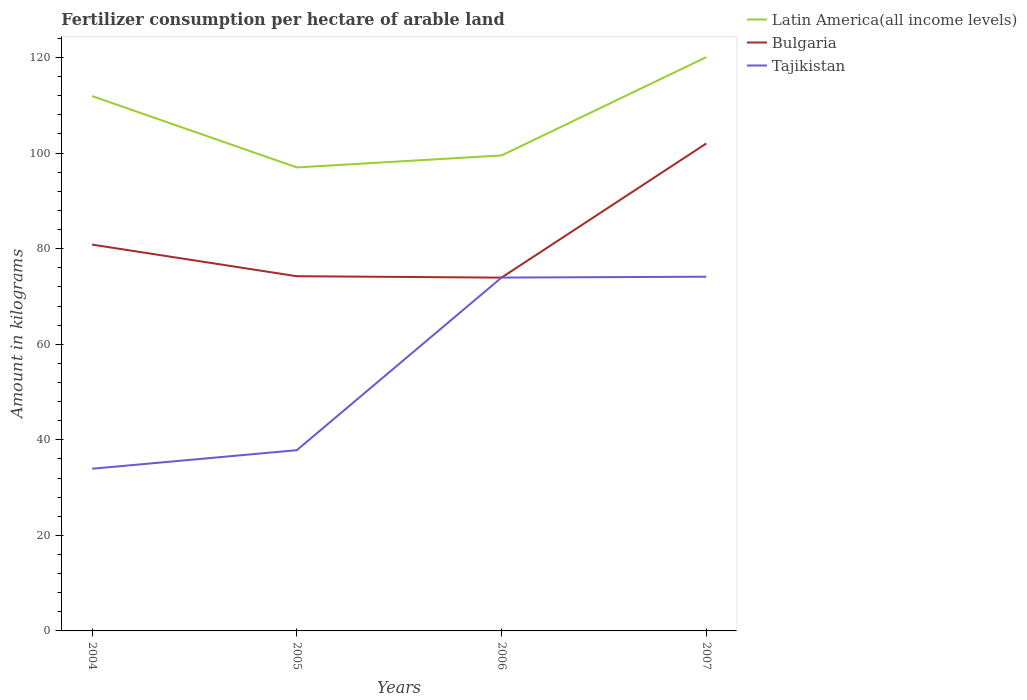Is the number of lines equal to the number of legend labels?
Keep it short and to the point. Yes. Across all years, what is the maximum amount of fertilizer consumption in Bulgaria?
Make the answer very short. 73.94. In which year was the amount of fertilizer consumption in Tajikistan maximum?
Offer a terse response. 2004. What is the total amount of fertilizer consumption in Latin America(all income levels) in the graph?
Your answer should be very brief. -20.57. What is the difference between the highest and the second highest amount of fertilizer consumption in Tajikistan?
Your response must be concise. 40.19. What is the difference between the highest and the lowest amount of fertilizer consumption in Latin America(all income levels)?
Offer a terse response. 2. Is the amount of fertilizer consumption in Bulgaria strictly greater than the amount of fertilizer consumption in Latin America(all income levels) over the years?
Provide a succinct answer. Yes. How many years are there in the graph?
Your answer should be compact. 4. What is the title of the graph?
Offer a very short reply. Fertilizer consumption per hectare of arable land. What is the label or title of the X-axis?
Your answer should be very brief. Years. What is the label or title of the Y-axis?
Keep it short and to the point. Amount in kilograms. What is the Amount in kilograms in Latin America(all income levels) in 2004?
Make the answer very short. 111.94. What is the Amount in kilograms in Bulgaria in 2004?
Provide a succinct answer. 80.85. What is the Amount in kilograms of Tajikistan in 2004?
Your response must be concise. 33.94. What is the Amount in kilograms of Latin America(all income levels) in 2005?
Your answer should be compact. 97. What is the Amount in kilograms of Bulgaria in 2005?
Your response must be concise. 74.23. What is the Amount in kilograms of Tajikistan in 2005?
Make the answer very short. 37.82. What is the Amount in kilograms in Latin America(all income levels) in 2006?
Your answer should be very brief. 99.51. What is the Amount in kilograms of Bulgaria in 2006?
Make the answer very short. 73.94. What is the Amount in kilograms of Tajikistan in 2006?
Give a very brief answer. 73.95. What is the Amount in kilograms of Latin America(all income levels) in 2007?
Provide a succinct answer. 120.08. What is the Amount in kilograms of Bulgaria in 2007?
Offer a terse response. 102.01. What is the Amount in kilograms of Tajikistan in 2007?
Make the answer very short. 74.13. Across all years, what is the maximum Amount in kilograms of Latin America(all income levels)?
Ensure brevity in your answer.  120.08. Across all years, what is the maximum Amount in kilograms in Bulgaria?
Your answer should be very brief. 102.01. Across all years, what is the maximum Amount in kilograms in Tajikistan?
Offer a terse response. 74.13. Across all years, what is the minimum Amount in kilograms in Latin America(all income levels)?
Offer a terse response. 97. Across all years, what is the minimum Amount in kilograms of Bulgaria?
Give a very brief answer. 73.94. Across all years, what is the minimum Amount in kilograms of Tajikistan?
Your answer should be very brief. 33.94. What is the total Amount in kilograms of Latin America(all income levels) in the graph?
Make the answer very short. 428.53. What is the total Amount in kilograms of Bulgaria in the graph?
Your answer should be compact. 331.03. What is the total Amount in kilograms in Tajikistan in the graph?
Give a very brief answer. 219.84. What is the difference between the Amount in kilograms in Latin America(all income levels) in 2004 and that in 2005?
Ensure brevity in your answer.  14.94. What is the difference between the Amount in kilograms in Bulgaria in 2004 and that in 2005?
Offer a terse response. 6.62. What is the difference between the Amount in kilograms in Tajikistan in 2004 and that in 2005?
Make the answer very short. -3.88. What is the difference between the Amount in kilograms in Latin America(all income levels) in 2004 and that in 2006?
Give a very brief answer. 12.43. What is the difference between the Amount in kilograms in Bulgaria in 2004 and that in 2006?
Keep it short and to the point. 6.91. What is the difference between the Amount in kilograms of Tajikistan in 2004 and that in 2006?
Your answer should be compact. -40.01. What is the difference between the Amount in kilograms of Latin America(all income levels) in 2004 and that in 2007?
Provide a short and direct response. -8.14. What is the difference between the Amount in kilograms in Bulgaria in 2004 and that in 2007?
Ensure brevity in your answer.  -21.16. What is the difference between the Amount in kilograms of Tajikistan in 2004 and that in 2007?
Provide a short and direct response. -40.19. What is the difference between the Amount in kilograms in Latin America(all income levels) in 2005 and that in 2006?
Provide a succinct answer. -2.5. What is the difference between the Amount in kilograms in Bulgaria in 2005 and that in 2006?
Offer a very short reply. 0.29. What is the difference between the Amount in kilograms of Tajikistan in 2005 and that in 2006?
Your response must be concise. -36.12. What is the difference between the Amount in kilograms in Latin America(all income levels) in 2005 and that in 2007?
Your answer should be compact. -23.08. What is the difference between the Amount in kilograms of Bulgaria in 2005 and that in 2007?
Make the answer very short. -27.78. What is the difference between the Amount in kilograms of Tajikistan in 2005 and that in 2007?
Provide a succinct answer. -36.3. What is the difference between the Amount in kilograms of Latin America(all income levels) in 2006 and that in 2007?
Provide a short and direct response. -20.57. What is the difference between the Amount in kilograms of Bulgaria in 2006 and that in 2007?
Provide a short and direct response. -28.07. What is the difference between the Amount in kilograms of Tajikistan in 2006 and that in 2007?
Keep it short and to the point. -0.18. What is the difference between the Amount in kilograms in Latin America(all income levels) in 2004 and the Amount in kilograms in Bulgaria in 2005?
Provide a succinct answer. 37.71. What is the difference between the Amount in kilograms in Latin America(all income levels) in 2004 and the Amount in kilograms in Tajikistan in 2005?
Your answer should be very brief. 74.11. What is the difference between the Amount in kilograms in Bulgaria in 2004 and the Amount in kilograms in Tajikistan in 2005?
Keep it short and to the point. 43.03. What is the difference between the Amount in kilograms in Latin America(all income levels) in 2004 and the Amount in kilograms in Bulgaria in 2006?
Offer a terse response. 38. What is the difference between the Amount in kilograms in Latin America(all income levels) in 2004 and the Amount in kilograms in Tajikistan in 2006?
Your answer should be very brief. 37.99. What is the difference between the Amount in kilograms of Bulgaria in 2004 and the Amount in kilograms of Tajikistan in 2006?
Your answer should be compact. 6.9. What is the difference between the Amount in kilograms in Latin America(all income levels) in 2004 and the Amount in kilograms in Bulgaria in 2007?
Give a very brief answer. 9.93. What is the difference between the Amount in kilograms of Latin America(all income levels) in 2004 and the Amount in kilograms of Tajikistan in 2007?
Offer a terse response. 37.81. What is the difference between the Amount in kilograms of Bulgaria in 2004 and the Amount in kilograms of Tajikistan in 2007?
Provide a succinct answer. 6.72. What is the difference between the Amount in kilograms of Latin America(all income levels) in 2005 and the Amount in kilograms of Bulgaria in 2006?
Make the answer very short. 23.06. What is the difference between the Amount in kilograms of Latin America(all income levels) in 2005 and the Amount in kilograms of Tajikistan in 2006?
Offer a very short reply. 23.05. What is the difference between the Amount in kilograms in Bulgaria in 2005 and the Amount in kilograms in Tajikistan in 2006?
Provide a short and direct response. 0.28. What is the difference between the Amount in kilograms in Latin America(all income levels) in 2005 and the Amount in kilograms in Bulgaria in 2007?
Keep it short and to the point. -5.01. What is the difference between the Amount in kilograms of Latin America(all income levels) in 2005 and the Amount in kilograms of Tajikistan in 2007?
Your response must be concise. 22.87. What is the difference between the Amount in kilograms of Bulgaria in 2005 and the Amount in kilograms of Tajikistan in 2007?
Ensure brevity in your answer.  0.1. What is the difference between the Amount in kilograms in Latin America(all income levels) in 2006 and the Amount in kilograms in Bulgaria in 2007?
Offer a very short reply. -2.5. What is the difference between the Amount in kilograms in Latin America(all income levels) in 2006 and the Amount in kilograms in Tajikistan in 2007?
Ensure brevity in your answer.  25.38. What is the difference between the Amount in kilograms in Bulgaria in 2006 and the Amount in kilograms in Tajikistan in 2007?
Offer a terse response. -0.19. What is the average Amount in kilograms of Latin America(all income levels) per year?
Make the answer very short. 107.13. What is the average Amount in kilograms of Bulgaria per year?
Provide a succinct answer. 82.76. What is the average Amount in kilograms of Tajikistan per year?
Offer a very short reply. 54.96. In the year 2004, what is the difference between the Amount in kilograms in Latin America(all income levels) and Amount in kilograms in Bulgaria?
Offer a terse response. 31.09. In the year 2004, what is the difference between the Amount in kilograms in Latin America(all income levels) and Amount in kilograms in Tajikistan?
Make the answer very short. 77.99. In the year 2004, what is the difference between the Amount in kilograms in Bulgaria and Amount in kilograms in Tajikistan?
Give a very brief answer. 46.91. In the year 2005, what is the difference between the Amount in kilograms in Latin America(all income levels) and Amount in kilograms in Bulgaria?
Give a very brief answer. 22.77. In the year 2005, what is the difference between the Amount in kilograms of Latin America(all income levels) and Amount in kilograms of Tajikistan?
Your answer should be compact. 59.18. In the year 2005, what is the difference between the Amount in kilograms of Bulgaria and Amount in kilograms of Tajikistan?
Ensure brevity in your answer.  36.41. In the year 2006, what is the difference between the Amount in kilograms in Latin America(all income levels) and Amount in kilograms in Bulgaria?
Ensure brevity in your answer.  25.57. In the year 2006, what is the difference between the Amount in kilograms of Latin America(all income levels) and Amount in kilograms of Tajikistan?
Offer a very short reply. 25.56. In the year 2006, what is the difference between the Amount in kilograms in Bulgaria and Amount in kilograms in Tajikistan?
Your answer should be very brief. -0.01. In the year 2007, what is the difference between the Amount in kilograms of Latin America(all income levels) and Amount in kilograms of Bulgaria?
Your answer should be compact. 18.07. In the year 2007, what is the difference between the Amount in kilograms in Latin America(all income levels) and Amount in kilograms in Tajikistan?
Make the answer very short. 45.95. In the year 2007, what is the difference between the Amount in kilograms of Bulgaria and Amount in kilograms of Tajikistan?
Your answer should be very brief. 27.88. What is the ratio of the Amount in kilograms in Latin America(all income levels) in 2004 to that in 2005?
Offer a terse response. 1.15. What is the ratio of the Amount in kilograms of Bulgaria in 2004 to that in 2005?
Offer a terse response. 1.09. What is the ratio of the Amount in kilograms in Tajikistan in 2004 to that in 2005?
Offer a very short reply. 0.9. What is the ratio of the Amount in kilograms of Latin America(all income levels) in 2004 to that in 2006?
Your response must be concise. 1.12. What is the ratio of the Amount in kilograms in Bulgaria in 2004 to that in 2006?
Your answer should be very brief. 1.09. What is the ratio of the Amount in kilograms in Tajikistan in 2004 to that in 2006?
Keep it short and to the point. 0.46. What is the ratio of the Amount in kilograms in Latin America(all income levels) in 2004 to that in 2007?
Give a very brief answer. 0.93. What is the ratio of the Amount in kilograms in Bulgaria in 2004 to that in 2007?
Offer a very short reply. 0.79. What is the ratio of the Amount in kilograms in Tajikistan in 2004 to that in 2007?
Give a very brief answer. 0.46. What is the ratio of the Amount in kilograms in Latin America(all income levels) in 2005 to that in 2006?
Offer a terse response. 0.97. What is the ratio of the Amount in kilograms in Bulgaria in 2005 to that in 2006?
Ensure brevity in your answer.  1. What is the ratio of the Amount in kilograms of Tajikistan in 2005 to that in 2006?
Offer a terse response. 0.51. What is the ratio of the Amount in kilograms of Latin America(all income levels) in 2005 to that in 2007?
Your answer should be compact. 0.81. What is the ratio of the Amount in kilograms in Bulgaria in 2005 to that in 2007?
Your response must be concise. 0.73. What is the ratio of the Amount in kilograms of Tajikistan in 2005 to that in 2007?
Make the answer very short. 0.51. What is the ratio of the Amount in kilograms in Latin America(all income levels) in 2006 to that in 2007?
Provide a succinct answer. 0.83. What is the ratio of the Amount in kilograms in Bulgaria in 2006 to that in 2007?
Offer a terse response. 0.72. What is the ratio of the Amount in kilograms of Tajikistan in 2006 to that in 2007?
Provide a succinct answer. 1. What is the difference between the highest and the second highest Amount in kilograms of Latin America(all income levels)?
Make the answer very short. 8.14. What is the difference between the highest and the second highest Amount in kilograms of Bulgaria?
Make the answer very short. 21.16. What is the difference between the highest and the second highest Amount in kilograms in Tajikistan?
Your answer should be very brief. 0.18. What is the difference between the highest and the lowest Amount in kilograms in Latin America(all income levels)?
Your response must be concise. 23.08. What is the difference between the highest and the lowest Amount in kilograms in Bulgaria?
Keep it short and to the point. 28.07. What is the difference between the highest and the lowest Amount in kilograms in Tajikistan?
Ensure brevity in your answer.  40.19. 